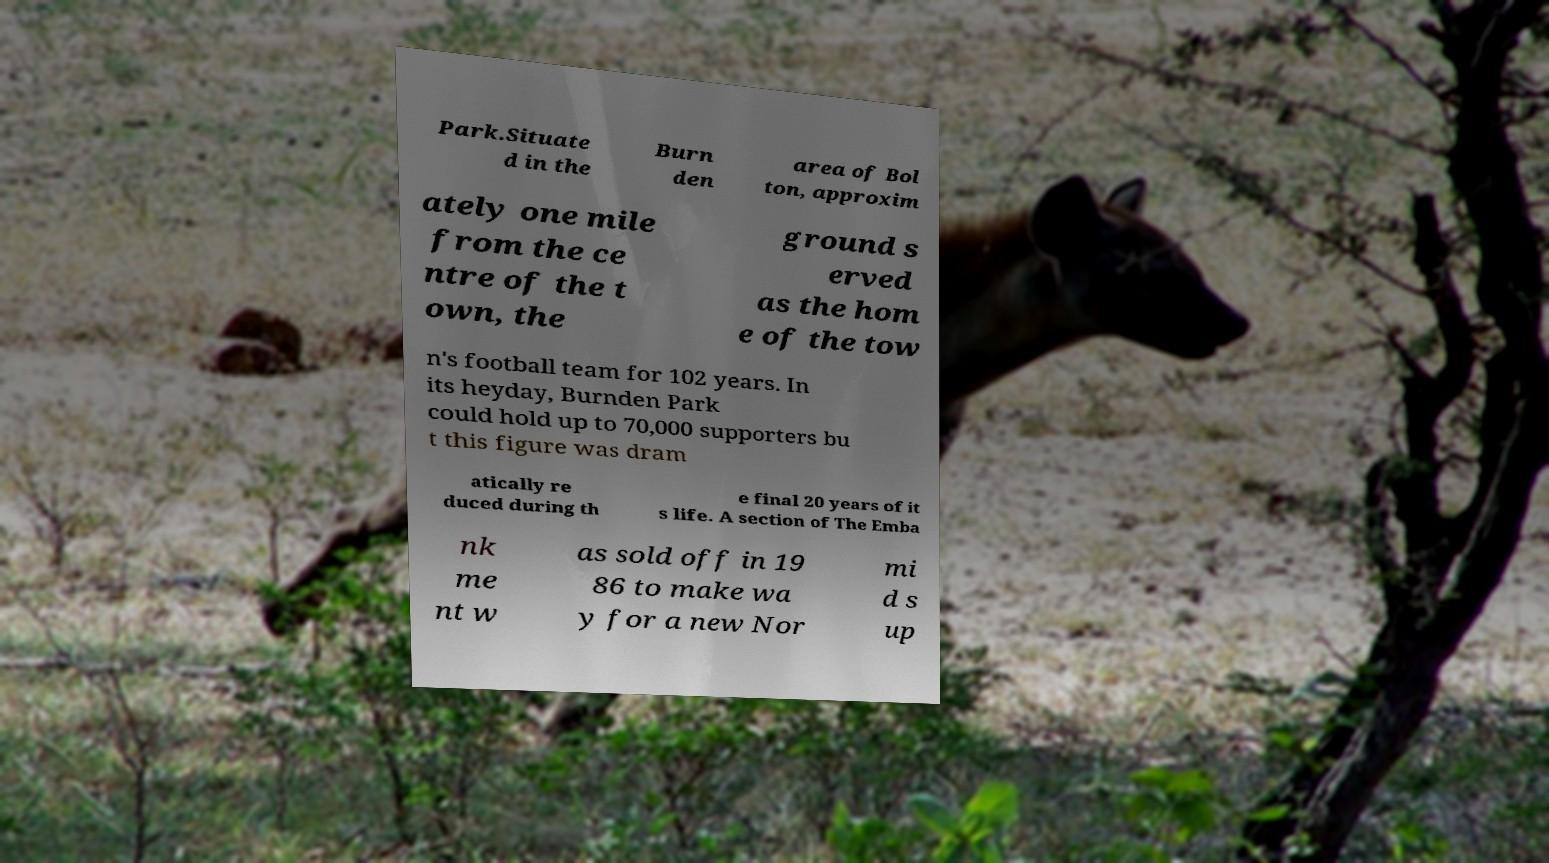I need the written content from this picture converted into text. Can you do that? Park.Situate d in the Burn den area of Bol ton, approxim ately one mile from the ce ntre of the t own, the ground s erved as the hom e of the tow n's football team for 102 years. In its heyday, Burnden Park could hold up to 70,000 supporters bu t this figure was dram atically re duced during th e final 20 years of it s life. A section of The Emba nk me nt w as sold off in 19 86 to make wa y for a new Nor mi d s up 